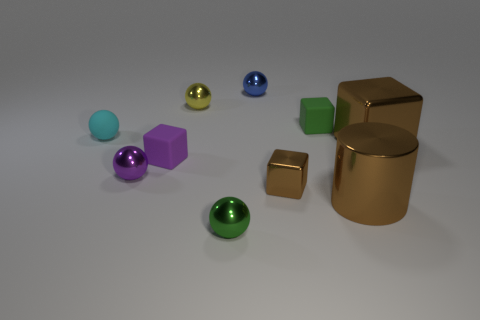There is another green thing that is the same size as the green matte thing; what is its shape?
Your answer should be compact. Sphere. There is a shiny ball that is in front of the tiny purple shiny ball; is it the same size as the block that is in front of the purple sphere?
Ensure brevity in your answer.  Yes. What number of metallic things are there?
Ensure brevity in your answer.  7. What is the size of the rubber block in front of the brown metallic block behind the small matte block left of the blue ball?
Give a very brief answer. Small. Do the shiny cylinder and the large shiny block have the same color?
Keep it short and to the point. Yes. What number of cubes are in front of the small rubber sphere?
Your response must be concise. 3. Are there an equal number of purple matte blocks in front of the green sphere and yellow metallic blocks?
Offer a very short reply. Yes. How many objects are either large yellow matte cubes or purple metal spheres?
Offer a very short reply. 1. There is a small rubber object to the right of the green object that is in front of the cyan matte ball; what shape is it?
Offer a terse response. Cube. What is the shape of the blue thing that is made of the same material as the purple ball?
Your response must be concise. Sphere. 